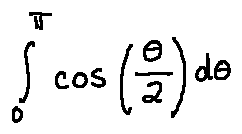Convert formula to latex. <formula><loc_0><loc_0><loc_500><loc_500>\int \lim i t s _ { 0 } ^ { \pi } \cos ( \frac { \theta } { 2 } ) d \theta</formula> 